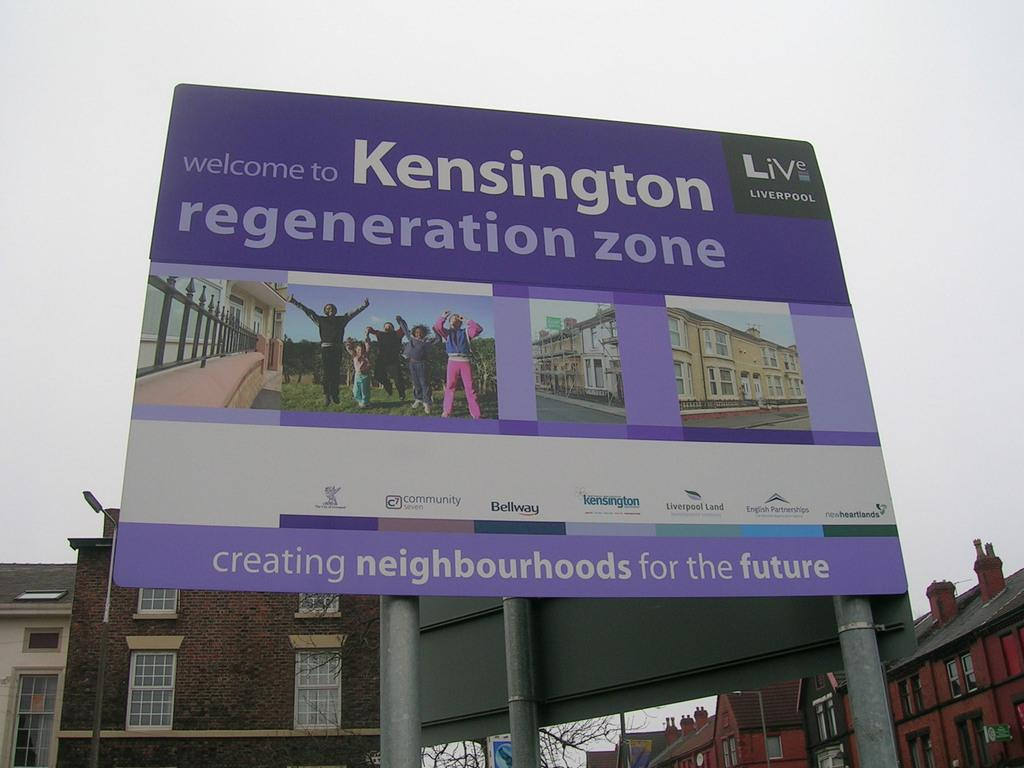<image>
Render a clear and concise summary of the photo. A billboard welcoming you to Kensington which creates neighborhoods for the future. 